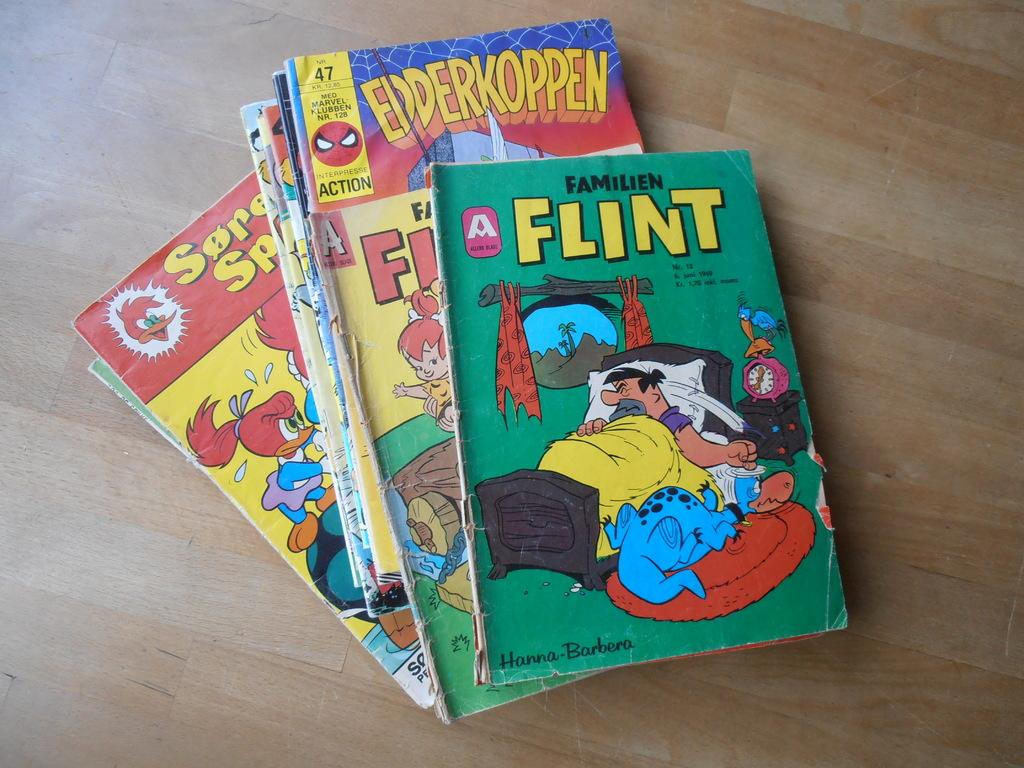<image>
Render a clear and concise summary of the photo. a variety of comic books, one of them being the flintstones 